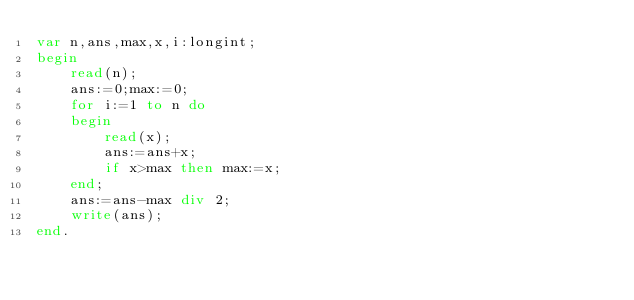<code> <loc_0><loc_0><loc_500><loc_500><_Pascal_>var n,ans,max,x,i:longint;
begin 
	read(n);
	ans:=0;max:=0;
	for i:=1 to n do 
	begin 
		read(x);
		ans:=ans+x;
		if x>max then max:=x;
	end;
	ans:=ans-max div 2;
	write(ans);
end.</code> 